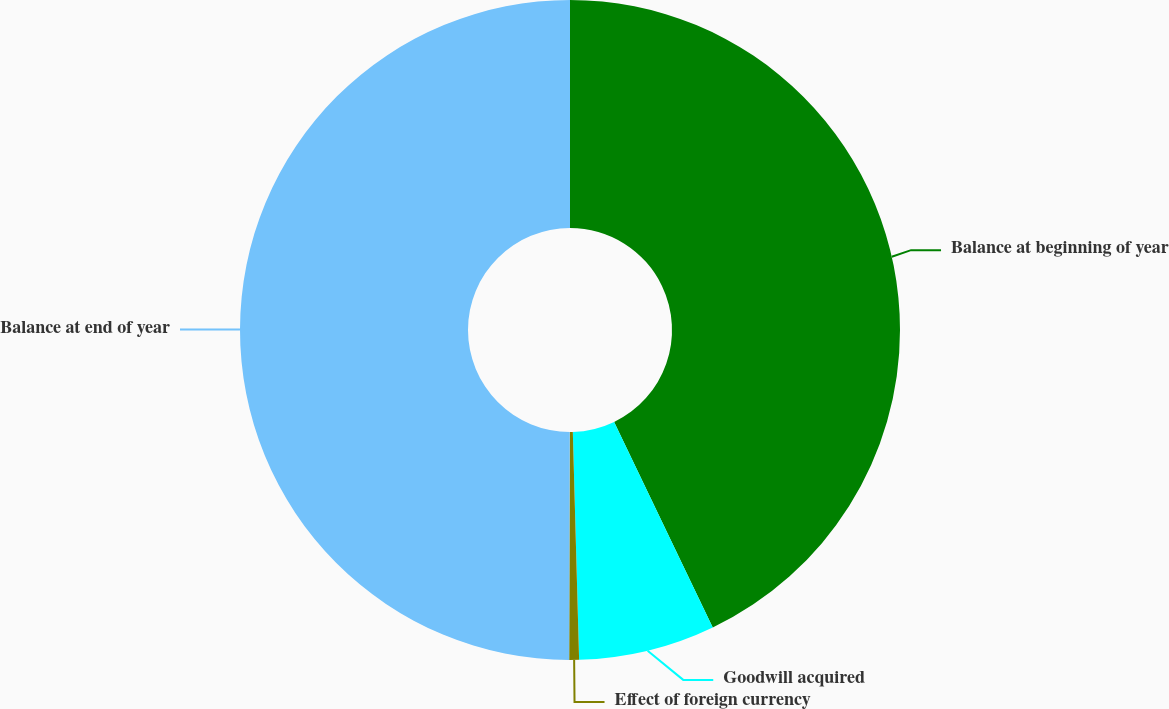Convert chart to OTSL. <chart><loc_0><loc_0><loc_500><loc_500><pie_chart><fcel>Balance at beginning of year<fcel>Goodwill acquired<fcel>Effect of foreign currency<fcel>Balance at end of year<nl><fcel>42.88%<fcel>6.68%<fcel>0.48%<fcel>49.96%<nl></chart> 